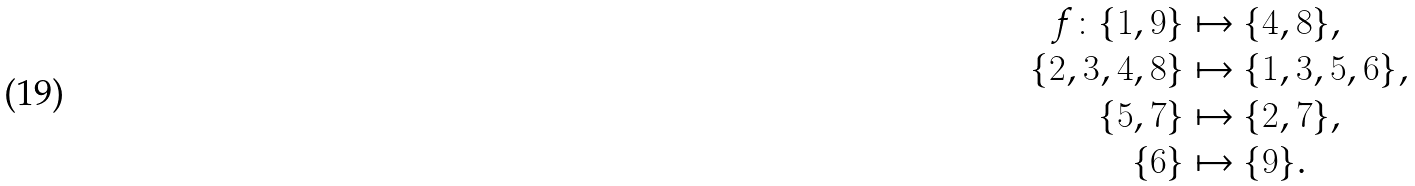Convert formula to latex. <formula><loc_0><loc_0><loc_500><loc_500>f \colon \{ 1 , 9 \} & \mapsto \{ 4 , 8 \} , \\ \{ 2 , 3 , 4 , 8 \} & \mapsto \{ 1 , 3 , 5 , 6 \} , \\ \{ 5 , 7 \} & \mapsto \{ 2 , 7 \} , \\ \{ 6 \} & \mapsto \{ 9 \} .</formula> 